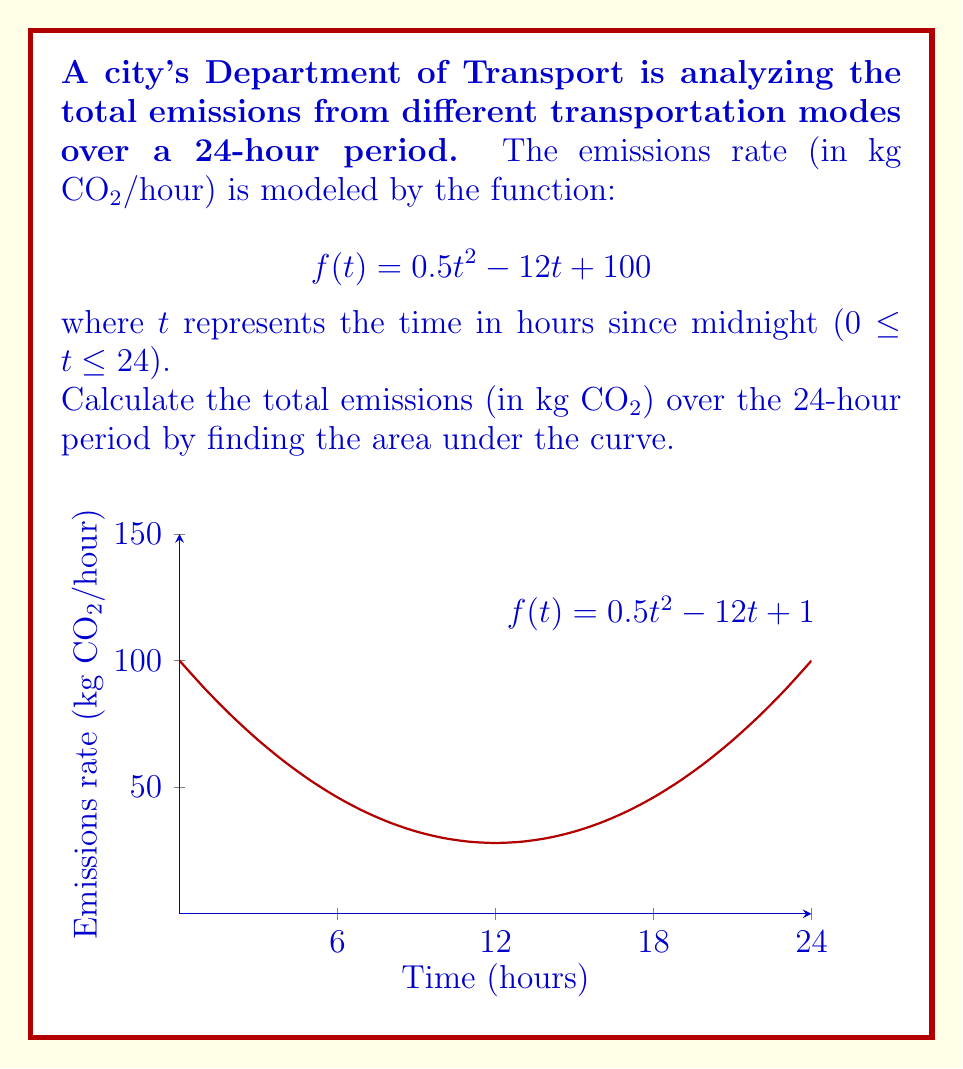Teach me how to tackle this problem. To find the total emissions over the 24-hour period, we need to calculate the definite integral of the emissions rate function from t = 0 to t = 24.

Step 1: Set up the definite integral
$$\int_0^{24} (0.5t^2 - 12t + 100) dt$$

Step 2: Integrate the function
$$\left[\frac{1}{6}t^3 - 6t^2 + 100t\right]_0^{24}$$

Step 3: Evaluate the integral at the upper and lower bounds
Upper bound (t = 24):
$$\frac{1}{6}(24)^3 - 6(24)^2 + 100(24) = 2304 - 3456 + 2400 = 1248$$

Lower bound (t = 0):
$$\frac{1}{6}(0)^3 - 6(0)^2 + 100(0) = 0$$

Step 4: Subtract the lower bound from the upper bound
$$1248 - 0 = 1248$$

Therefore, the total emissions over the 24-hour period is 1248 kg CO₂.
Answer: 1248 kg CO₂ 